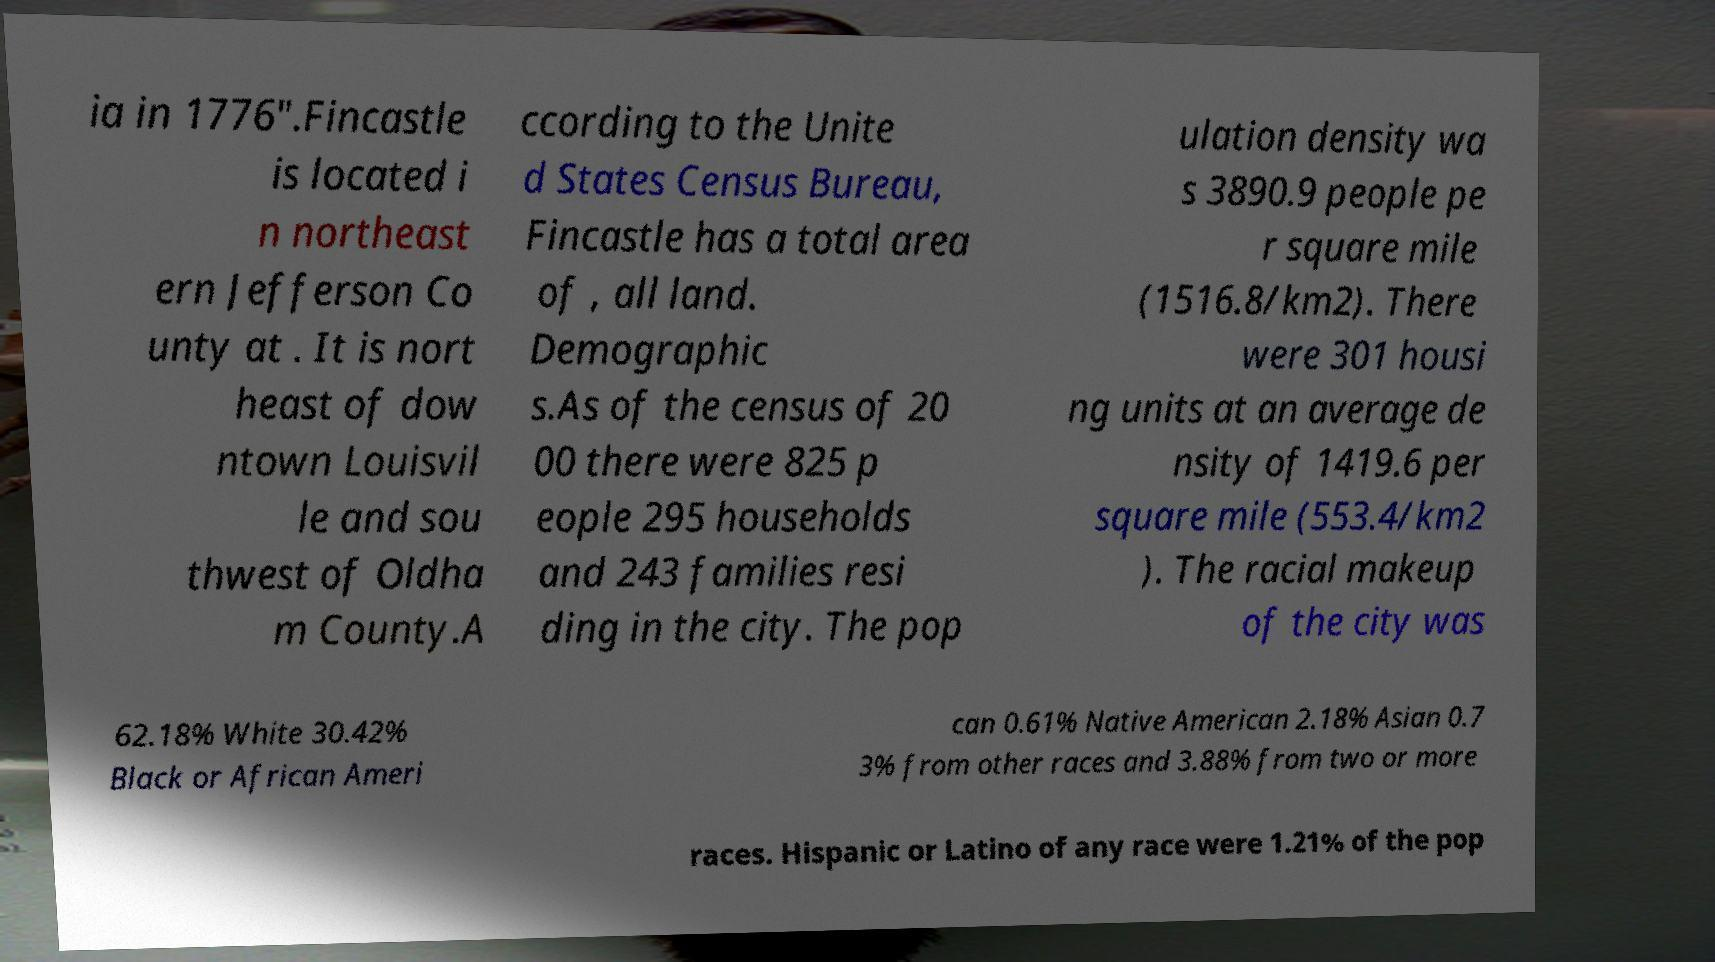Please read and relay the text visible in this image. What does it say? ia in 1776".Fincastle is located i n northeast ern Jefferson Co unty at . It is nort heast of dow ntown Louisvil le and sou thwest of Oldha m County.A ccording to the Unite d States Census Bureau, Fincastle has a total area of , all land. Demographic s.As of the census of 20 00 there were 825 p eople 295 households and 243 families resi ding in the city. The pop ulation density wa s 3890.9 people pe r square mile (1516.8/km2). There were 301 housi ng units at an average de nsity of 1419.6 per square mile (553.4/km2 ). The racial makeup of the city was 62.18% White 30.42% Black or African Ameri can 0.61% Native American 2.18% Asian 0.7 3% from other races and 3.88% from two or more races. Hispanic or Latino of any race were 1.21% of the pop 